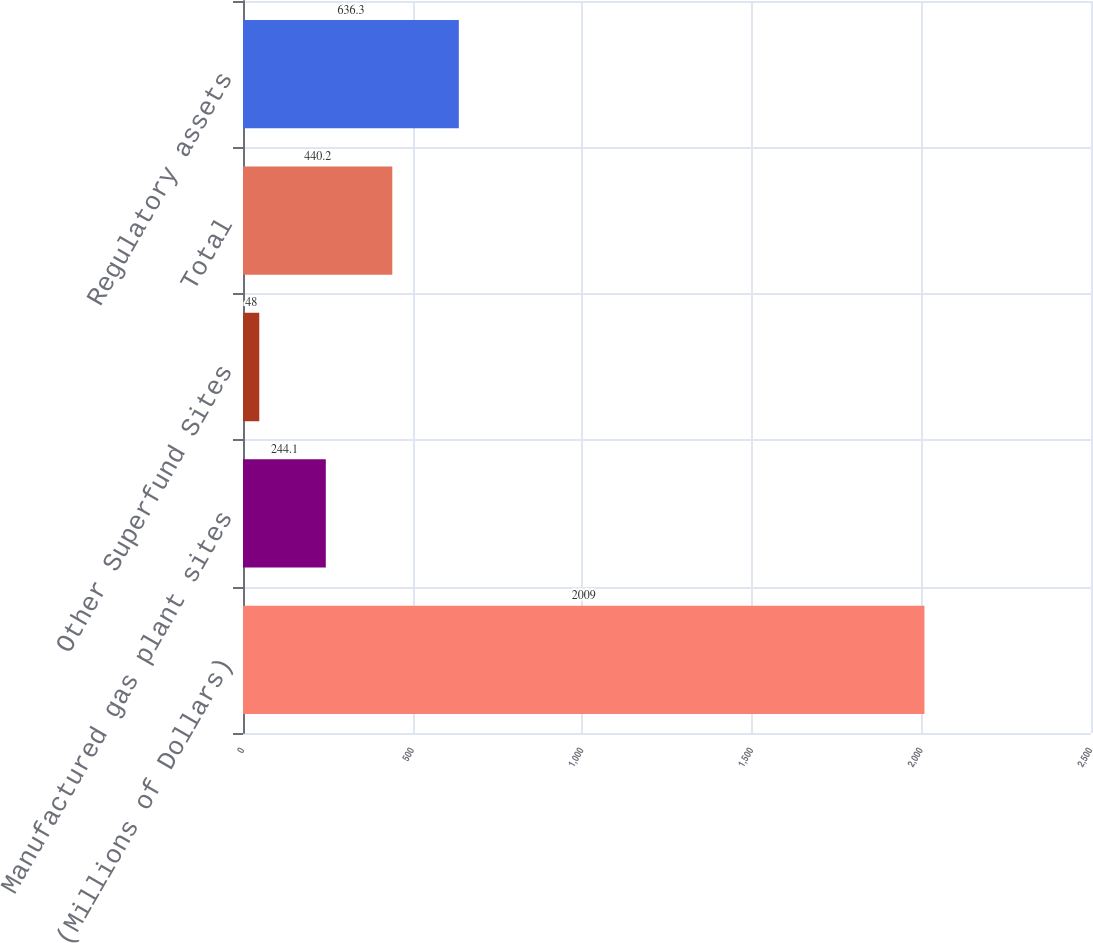<chart> <loc_0><loc_0><loc_500><loc_500><bar_chart><fcel>(Millions of Dollars)<fcel>Manufactured gas plant sites<fcel>Other Superfund Sites<fcel>Total<fcel>Regulatory assets<nl><fcel>2009<fcel>244.1<fcel>48<fcel>440.2<fcel>636.3<nl></chart> 